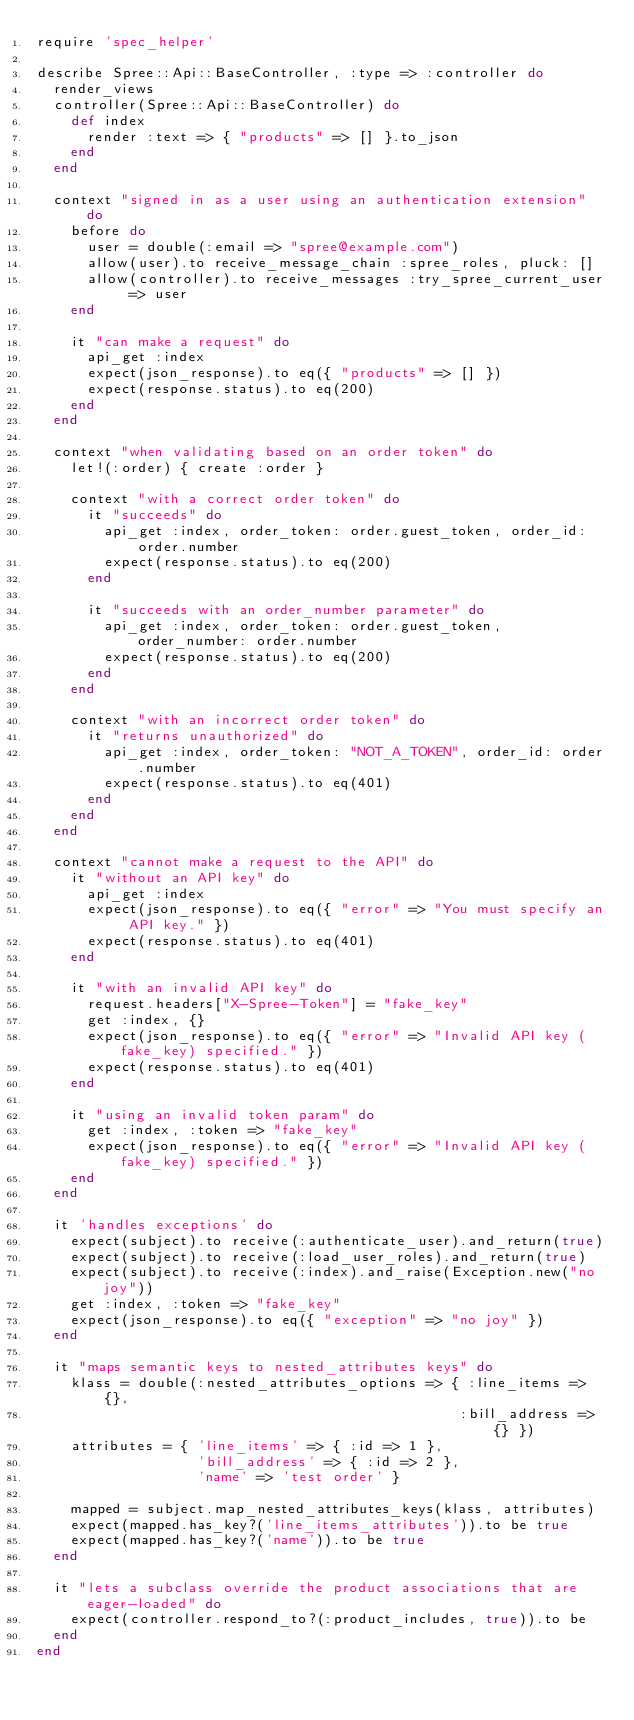Convert code to text. <code><loc_0><loc_0><loc_500><loc_500><_Ruby_>require 'spec_helper'

describe Spree::Api::BaseController, :type => :controller do
  render_views
  controller(Spree::Api::BaseController) do
    def index
      render :text => { "products" => [] }.to_json
    end
  end

  context "signed in as a user using an authentication extension" do
    before do
      user = double(:email => "spree@example.com")
      allow(user).to receive_message_chain :spree_roles, pluck: []
      allow(controller).to receive_messages :try_spree_current_user => user
    end

    it "can make a request" do
      api_get :index
      expect(json_response).to eq({ "products" => [] })
      expect(response.status).to eq(200)
    end
  end

  context "when validating based on an order token" do
    let!(:order) { create :order }

    context "with a correct order token" do
      it "succeeds" do
        api_get :index, order_token: order.guest_token, order_id: order.number
        expect(response.status).to eq(200)
      end

      it "succeeds with an order_number parameter" do
        api_get :index, order_token: order.guest_token, order_number: order.number
        expect(response.status).to eq(200)
      end
    end

    context "with an incorrect order token" do
      it "returns unauthorized" do
        api_get :index, order_token: "NOT_A_TOKEN", order_id: order.number
        expect(response.status).to eq(401)
      end
    end
  end

  context "cannot make a request to the API" do
    it "without an API key" do
      api_get :index
      expect(json_response).to eq({ "error" => "You must specify an API key." })
      expect(response.status).to eq(401)
    end

    it "with an invalid API key" do
      request.headers["X-Spree-Token"] = "fake_key"
      get :index, {}
      expect(json_response).to eq({ "error" => "Invalid API key (fake_key) specified." })
      expect(response.status).to eq(401)
    end

    it "using an invalid token param" do
      get :index, :token => "fake_key"
      expect(json_response).to eq({ "error" => "Invalid API key (fake_key) specified." })
    end
  end

  it 'handles exceptions' do
    expect(subject).to receive(:authenticate_user).and_return(true)
    expect(subject).to receive(:load_user_roles).and_return(true)
    expect(subject).to receive(:index).and_raise(Exception.new("no joy"))
    get :index, :token => "fake_key"
    expect(json_response).to eq({ "exception" => "no joy" })
  end

  it "maps semantic keys to nested_attributes keys" do
    klass = double(:nested_attributes_options => { :line_items => {},
                                                  :bill_address => {} })
    attributes = { 'line_items' => { :id => 1 },
                   'bill_address' => { :id => 2 },
                   'name' => 'test order' }

    mapped = subject.map_nested_attributes_keys(klass, attributes)
    expect(mapped.has_key?('line_items_attributes')).to be true
    expect(mapped.has_key?('name')).to be true
  end

  it "lets a subclass override the product associations that are eager-loaded" do
    expect(controller.respond_to?(:product_includes, true)).to be
  end
end
</code> 